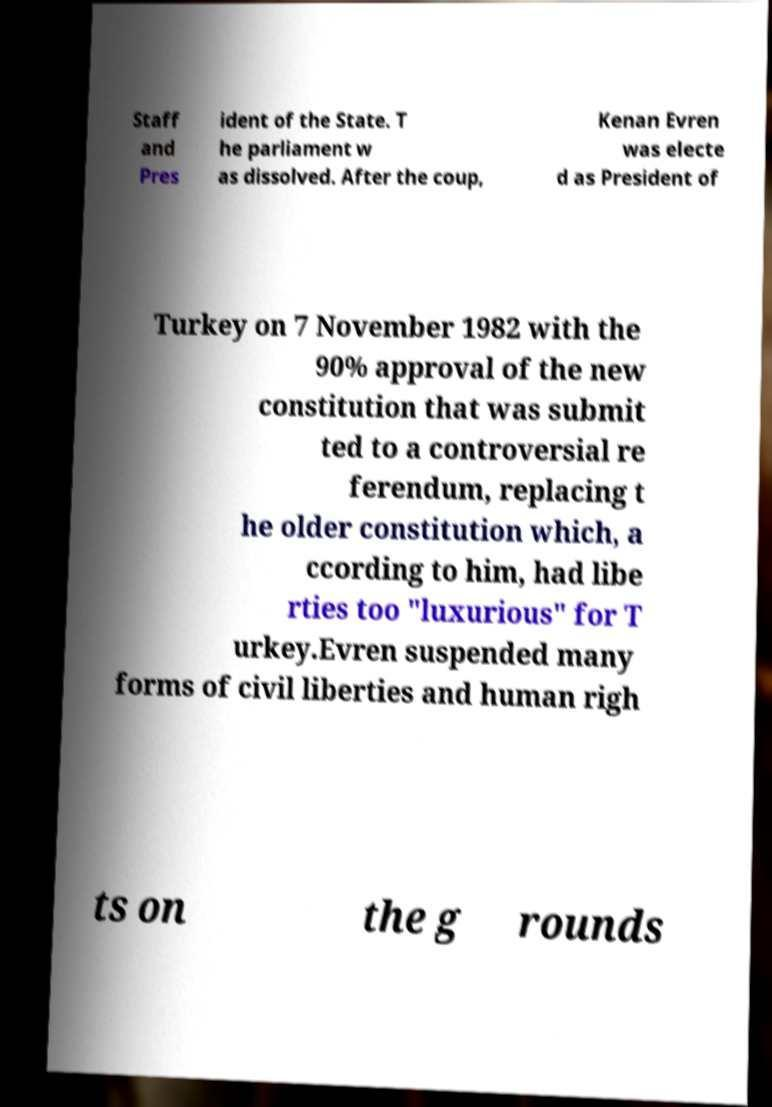What messages or text are displayed in this image? I need them in a readable, typed format. Staff and Pres ident of the State. T he parliament w as dissolved. After the coup, Kenan Evren was electe d as President of Turkey on 7 November 1982 with the 90% approval of the new constitution that was submit ted to a controversial re ferendum, replacing t he older constitution which, a ccording to him, had libe rties too "luxurious" for T urkey.Evren suspended many forms of civil liberties and human righ ts on the g rounds 